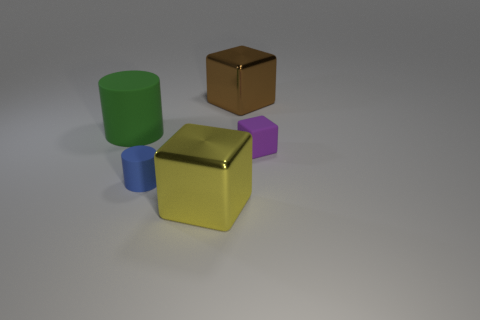Add 4 brown blocks. How many objects exist? 9 Subtract all blocks. How many objects are left? 2 Subtract 0 brown spheres. How many objects are left? 5 Subtract all rubber things. Subtract all big yellow metal blocks. How many objects are left? 1 Add 4 small cylinders. How many small cylinders are left? 5 Add 3 purple metallic things. How many purple metallic things exist? 3 